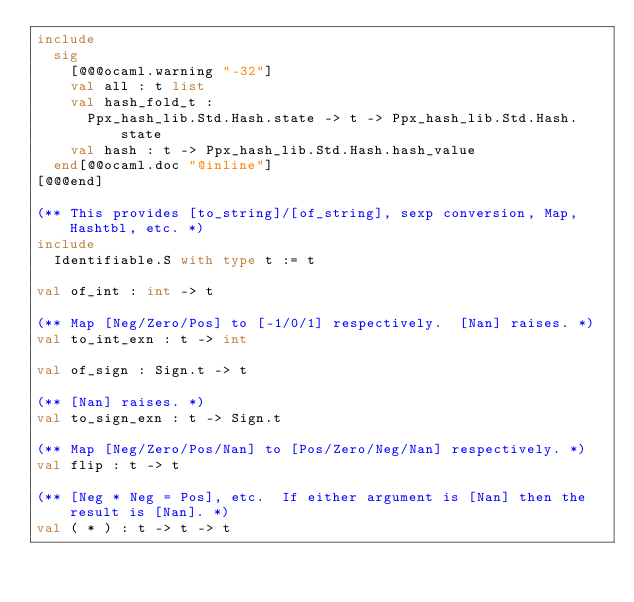Convert code to text. <code><loc_0><loc_0><loc_500><loc_500><_OCaml_>include
  sig
    [@@@ocaml.warning "-32"]
    val all : t list
    val hash_fold_t :
      Ppx_hash_lib.Std.Hash.state -> t -> Ppx_hash_lib.Std.Hash.state
    val hash : t -> Ppx_hash_lib.Std.Hash.hash_value
  end[@@ocaml.doc "@inline"]
[@@@end]

(** This provides [to_string]/[of_string], sexp conversion, Map, Hashtbl, etc. *)
include
  Identifiable.S with type t := t

val of_int : int -> t

(** Map [Neg/Zero/Pos] to [-1/0/1] respectively.  [Nan] raises. *)
val to_int_exn : t -> int

val of_sign : Sign.t -> t

(** [Nan] raises. *)
val to_sign_exn : t -> Sign.t

(** Map [Neg/Zero/Pos/Nan] to [Pos/Zero/Neg/Nan] respectively. *)
val flip : t -> t

(** [Neg * Neg = Pos], etc.  If either argument is [Nan] then the result is [Nan]. *)
val ( * ) : t -> t -> t
</code> 